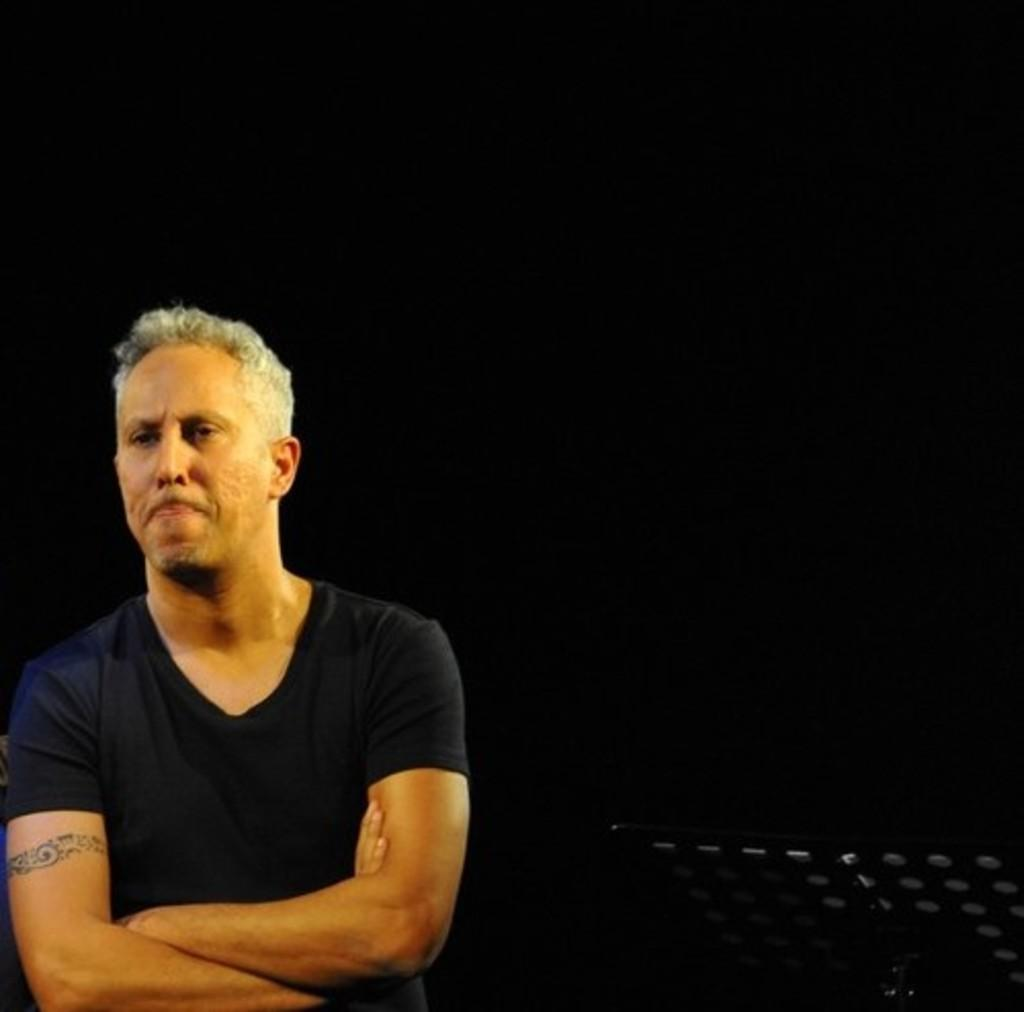What is the main subject of the image? There is a man standing in the image. Can you describe any distinguishing features of the man? The man has a tattoo on his arm. What can be seen in the background of the image? The background behind the man is dark. What type of butter is being spread on the man's toe in the image? There is no butter or any reference to a man's toe in the image; it only features a man standing with a tattoo on his arm. 